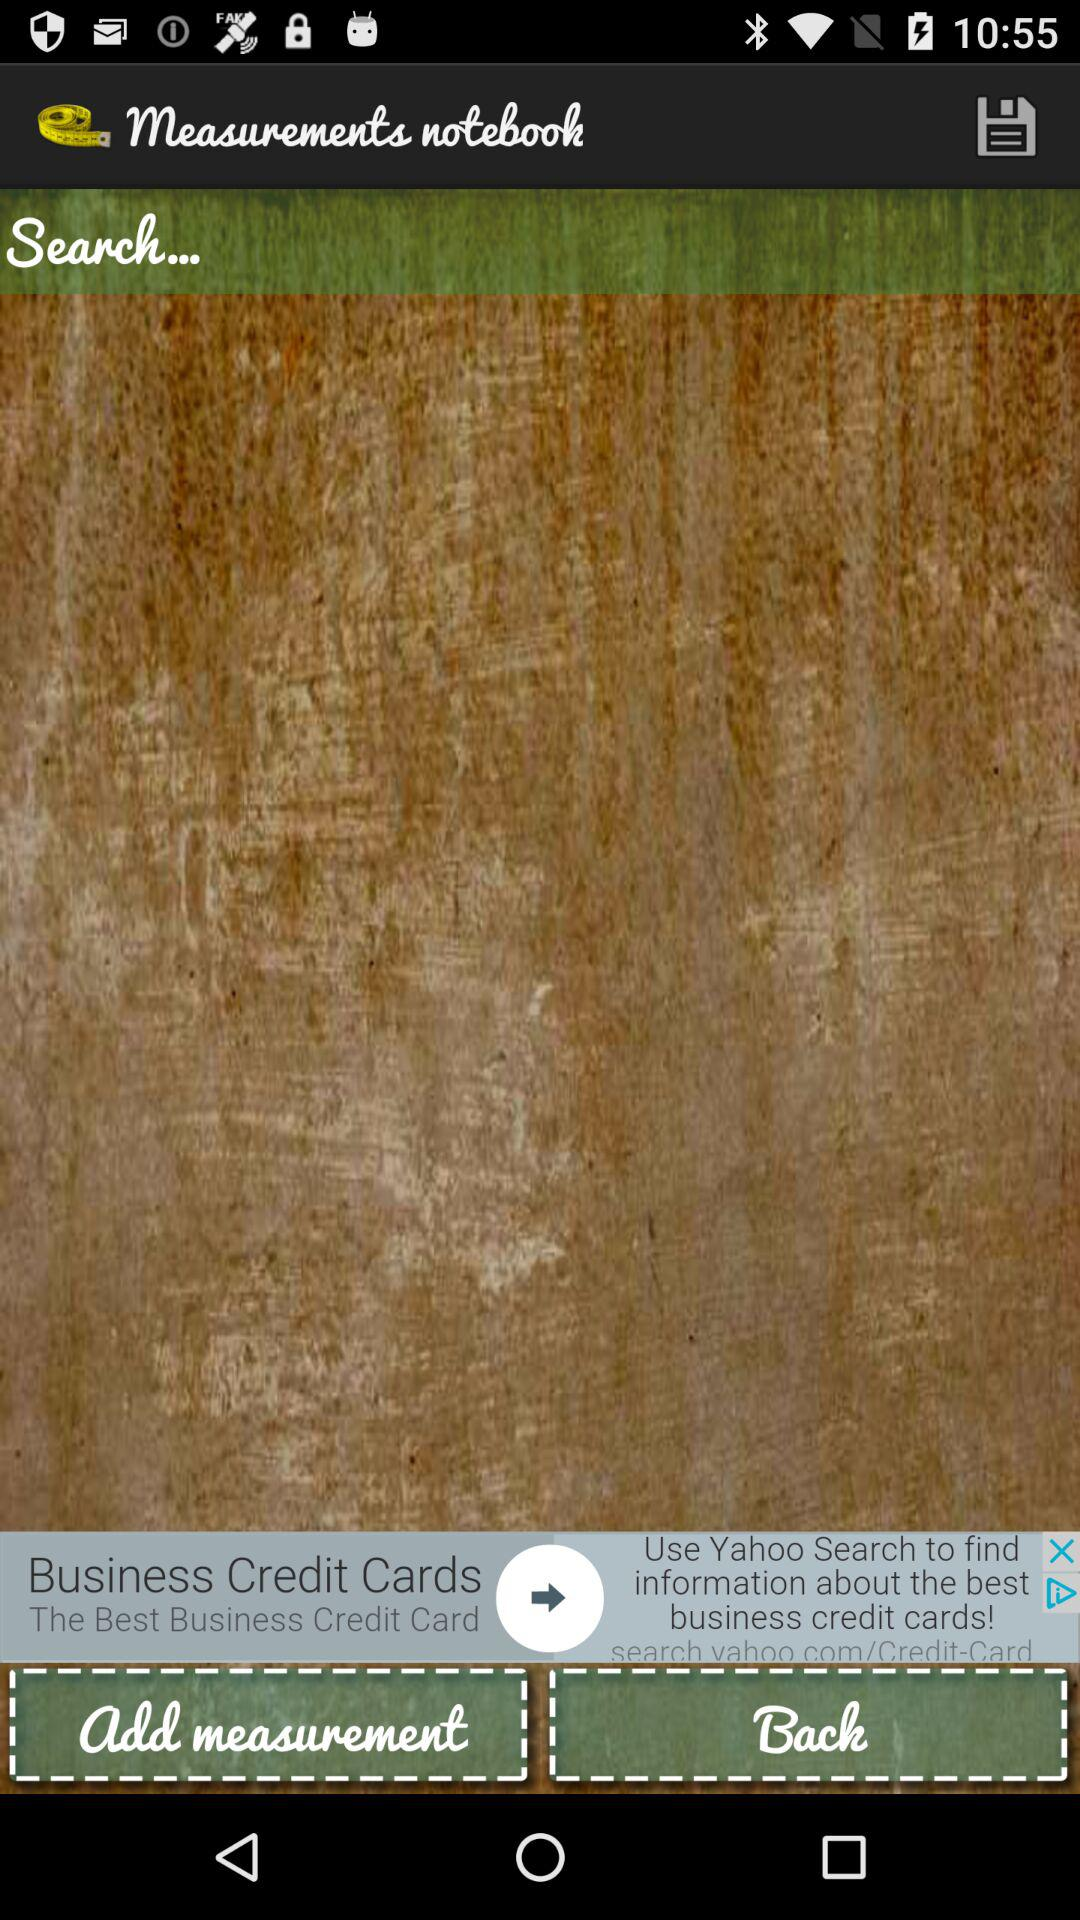What is the name of the application? The name of the application is "Measurements notebook". 